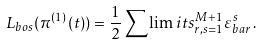<formula> <loc_0><loc_0><loc_500><loc_500>L _ { b o s } ( \pi ^ { ( 1 ) } ( t ) ) = \frac { 1 } { 2 } \sum \lim i t s _ { r , s = 1 } ^ { M + 1 } \varepsilon _ { b a r } ^ { s } \, .</formula> 